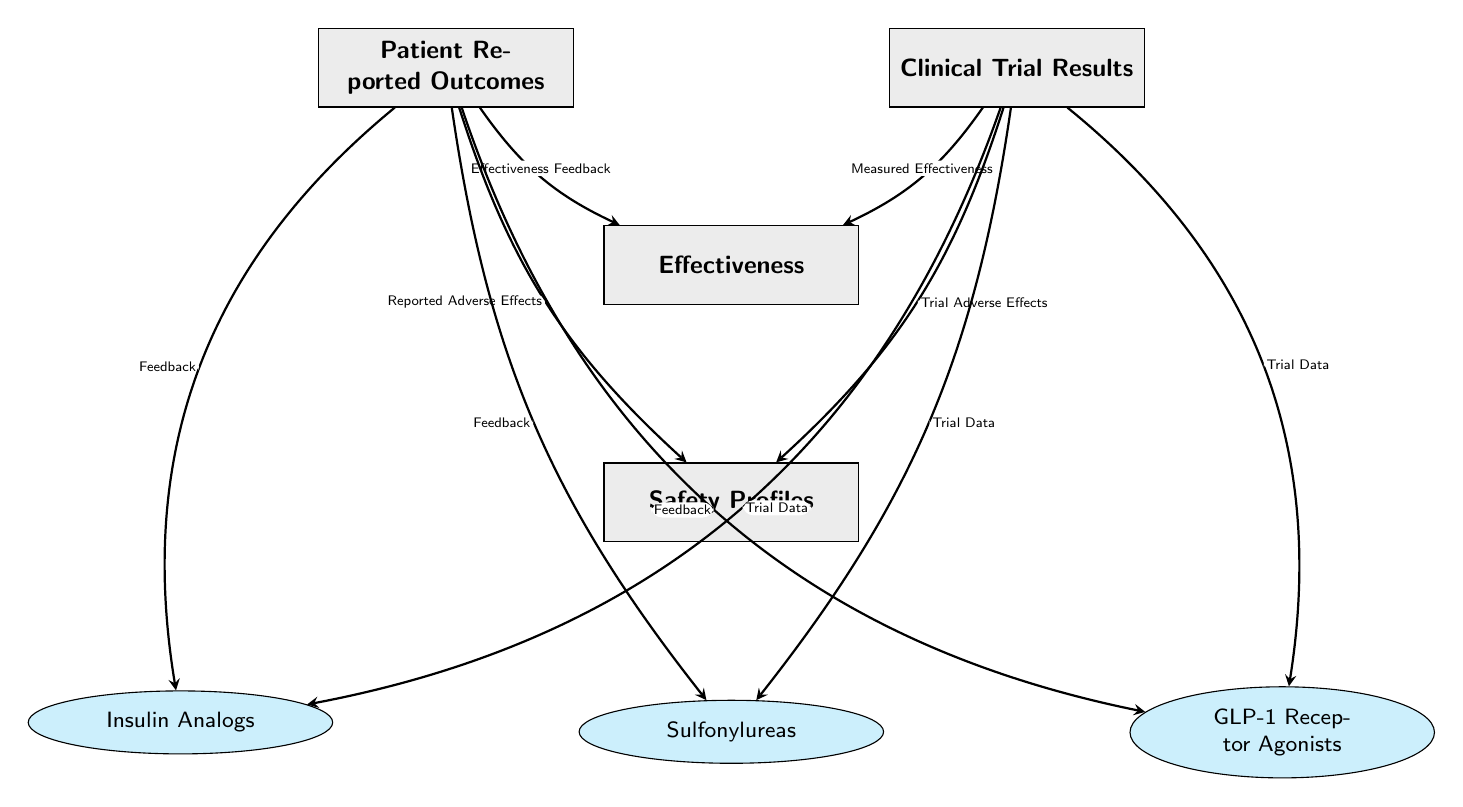What are the four main components in the diagram? The diagram contains four main components which are Patient Reported Outcomes, Clinical Trial Results, Effectiveness, and Safety Profiles. These are labeled distinctly as central themes in the study of diabetes medications.
Answer: Patient Reported Outcomes, Clinical Trial Results, Effectiveness, Safety Profiles How many types of diabetes medications are represented in the diagram? There are three types of diabetes medications in the diagram, listed as Insulin Analogs, Sulfonylureas, and GLP-1 Receptor Agonists. Each is connected to both Patient Reported Outcomes and Clinical Trial Results.
Answer: Three What does "Effectiveness Feedback" link to in the diagram? "Effectiveness Feedback" is linked to the Effectiveness node, indicating how patient reported outcomes influence the perceived effectiveness of diabetes medications.
Answer: Effectiveness What is the relationship between Clinical Trial Results and Safety Profiles? Clinical Trial Results and Safety Profiles are connected by the arrow labeled "Trial Adverse Effects," showing that clinical trials report on the safety profiles of the medications based on trial data.
Answer: Trial Adverse Effects Which medication type has a feedback connection that impacts the Patient Reported Outcomes? The feedback connections from Patient Reported Outcomes are present for all three medication types (Insulin Analogs, Sulfonylureas, GLP-1 Receptor Agonists). Thus, they all have feedback connections impacting the Patient Reported Outcomes.
Answer: All three How does the diagram indicate the role of ‘Measured Effectiveness’? "Measured Effectiveness" connects to the Effectiveness node from Clinical Trial Results, indicating that the effectiveness of diabetes medications is quantified through clinical trials.
Answer: Effectiveness What does the arrow labeled "Reported Adverse Effects" indicate? The arrow labeled "Reported Adverse Effects" indicates that patient feedback provides information on adverse effects related to diabetes medications, which can influence the safety profiles observed for these medications.
Answer: Safety Profiles In which direction do the arrows connecting Patient Reported Outcomes and Effectiveness point? The arrows connecting Patient Reported Outcomes and Effectiveness point toward the Effectiveness node, illustrating that patient outcomes are used to assess the effectiveness of treatments.
Answer: Toward Effectiveness Which aspect of diabetes medication does the node "Safety Profiles" summarize? The node "Safety Profiles" summarizes the safety-related information, including adverse effects reported from both patient experiences and clinical trials related to diabetes medications.
Answer: Safety-related information 